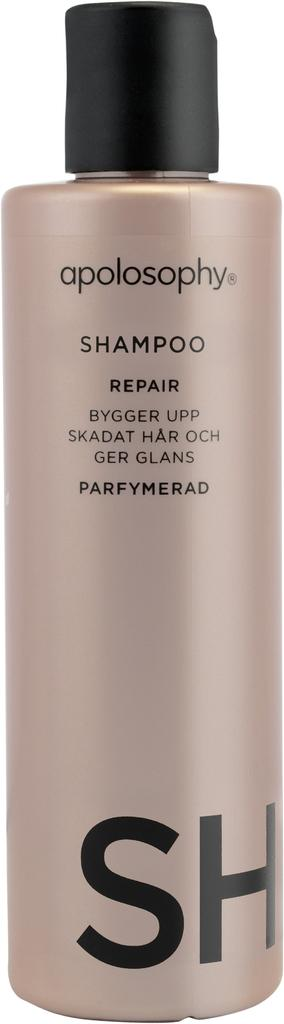<image>
Create a compact narrative representing the image presented. A pink bottle of apolosophy shampoo with a black lid. 